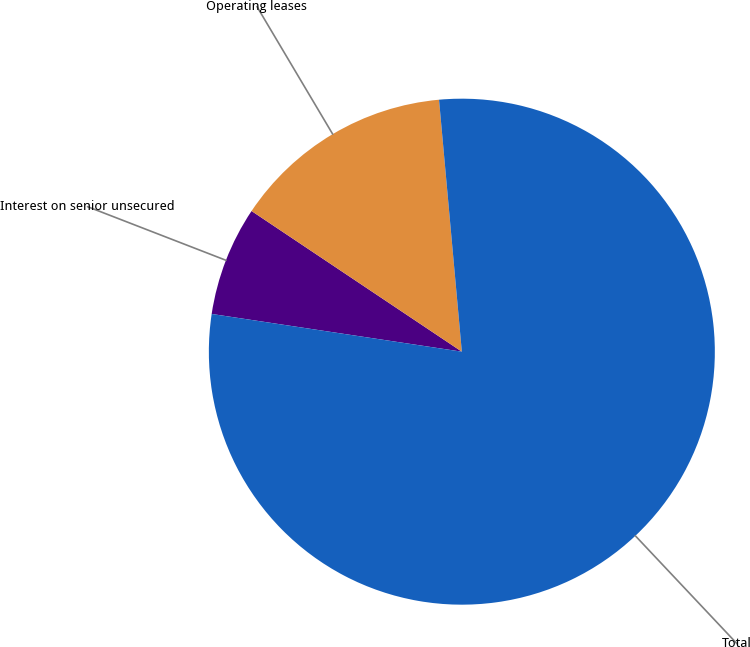<chart> <loc_0><loc_0><loc_500><loc_500><pie_chart><fcel>Interest on senior unsecured<fcel>Operating leases<fcel>Total<nl><fcel>7.0%<fcel>14.18%<fcel>78.82%<nl></chart> 